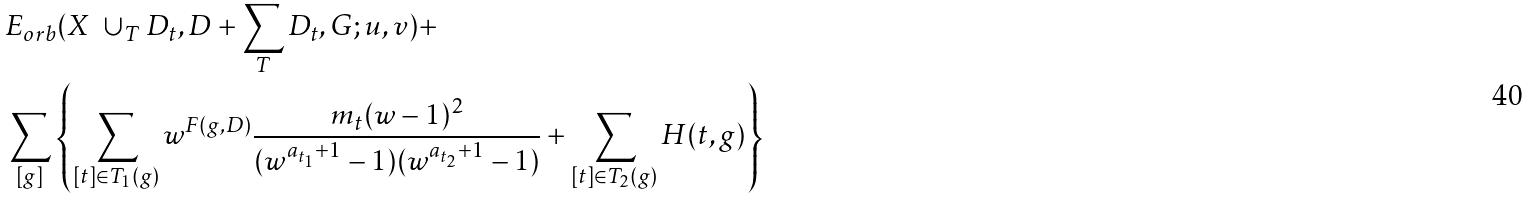<formula> <loc_0><loc_0><loc_500><loc_500>& E _ { o r b } ( X \ \cup _ { T } D _ { t } , D + \sum _ { T } D _ { t } , G ; u , v ) + \\ & \sum _ { [ g ] } \left \{ \sum _ { [ t ] \in T _ { 1 } ( g ) } w ^ { F ( g , D ) } \frac { m _ { t } ( w - 1 ) ^ { 2 } } { ( w ^ { a _ { t _ { 1 } } + 1 } - 1 ) ( w ^ { a _ { t _ { 2 } } + 1 } - 1 ) } + \sum _ { [ t ] \in T _ { 2 } ( g ) } H ( t , g ) \right \}</formula> 